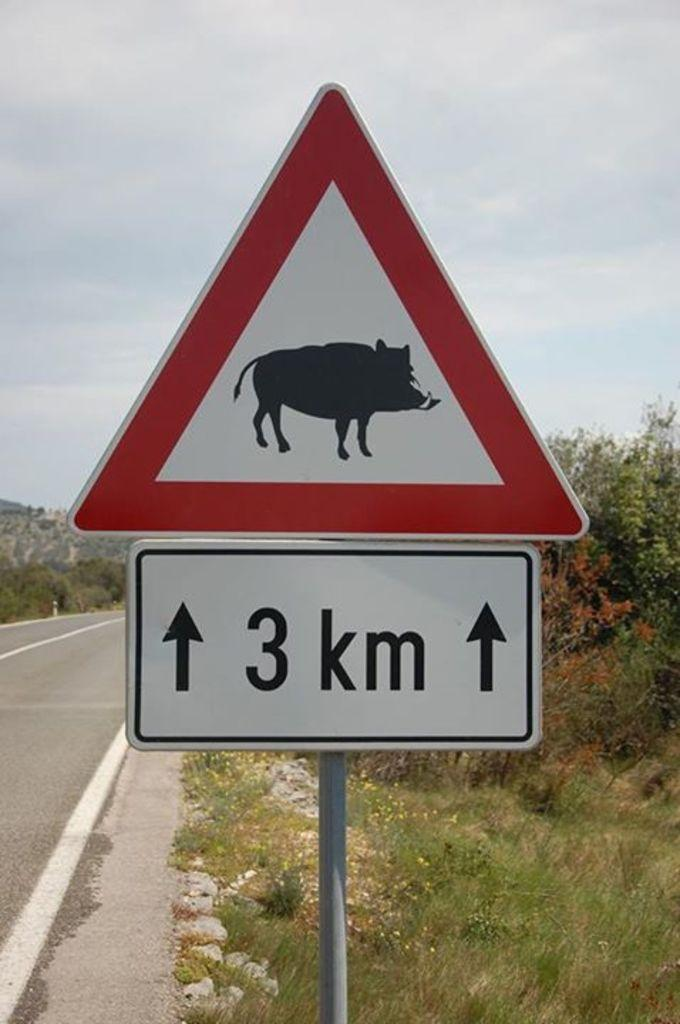What type of pathway is present in the image? There is a road in the image. What is located near the road in the image? There is a sign board in the image. What type of vegetation can be seen in the image? The ground with grass is visible in the image, and there are trees present as well. What can be seen in the background of the image? The sky is visible in the background of the image. What color is the scarf that the tree is wearing in the image? There is no scarf present in the image, and trees do not wear scarves. What type of hope can be seen in the image? There is no reference to hope in the image; it features a road, sign board, grass, trees, and the sky. 